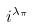Convert formula to latex. <formula><loc_0><loc_0><loc_500><loc_500>i ^ { \lambda _ { \pi } }</formula> 